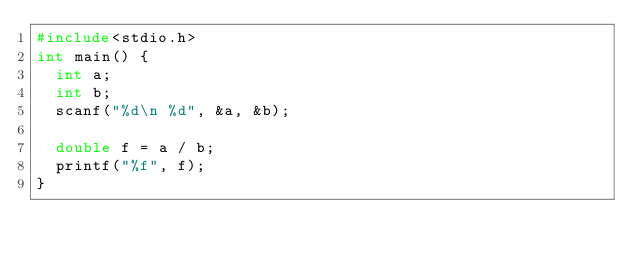Convert code to text. <code><loc_0><loc_0><loc_500><loc_500><_C_>#include<stdio.h>
int main() {
	int a;
	int	b;
	scanf("%d\n %d", &a, &b);

	double f = a / b;
	printf("%f", f);
}</code> 